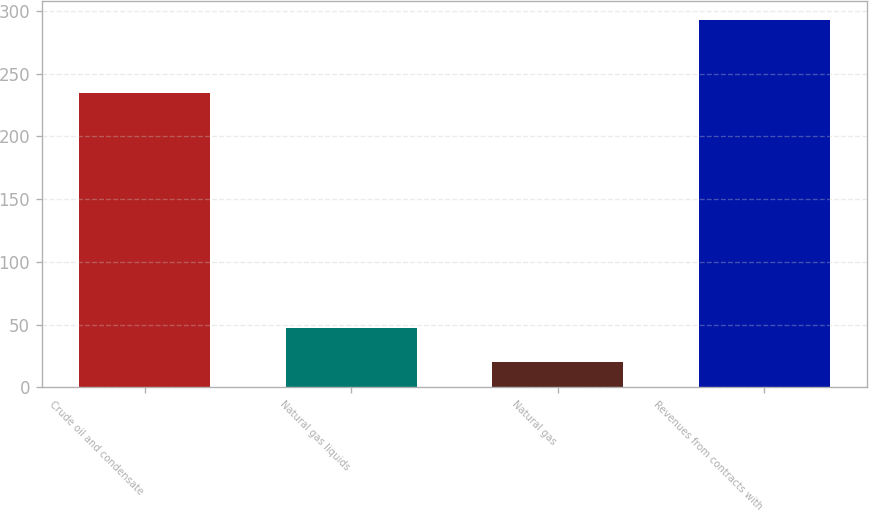Convert chart to OTSL. <chart><loc_0><loc_0><loc_500><loc_500><bar_chart><fcel>Crude oil and condensate<fcel>Natural gas liquids<fcel>Natural gas<fcel>Revenues from contracts with<nl><fcel>235<fcel>47.3<fcel>20<fcel>293<nl></chart> 